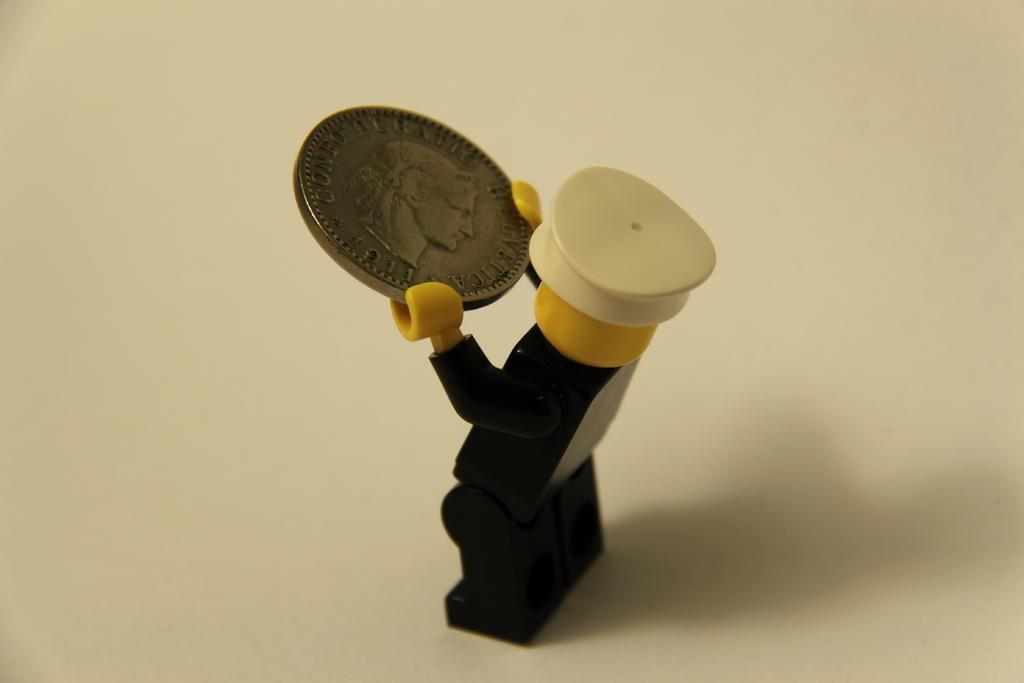Describe this image in one or two sentences. In the center of the image there is a depiction of a person holding a coin. At the bottom of the image there is a white color surface. 